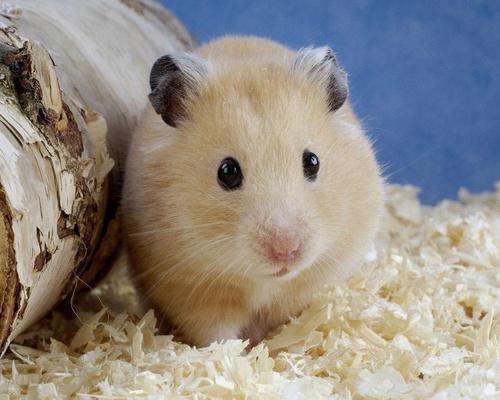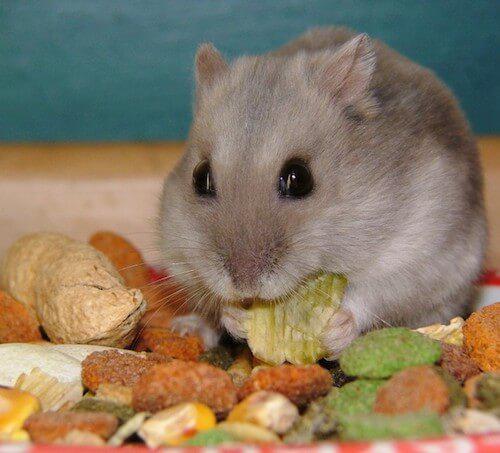The first image is the image on the left, the second image is the image on the right. Analyze the images presented: Is the assertion "One image shows a pet rodent standing on a bed of shredded material." valid? Answer yes or no. Yes. 